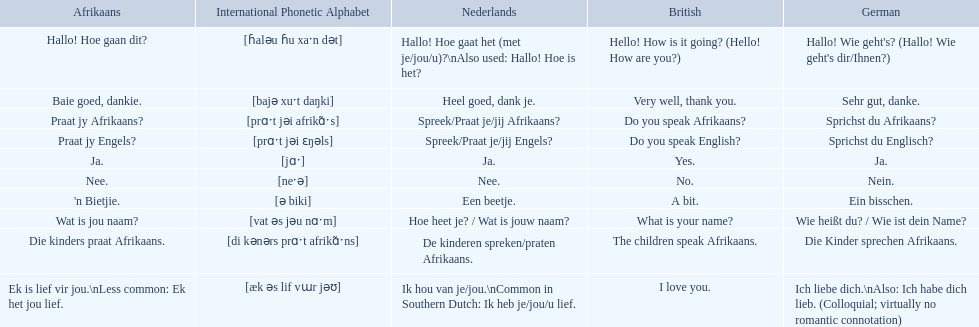Translate the following into german: die kinders praat afrikaans. Die Kinder sprechen Afrikaans. 